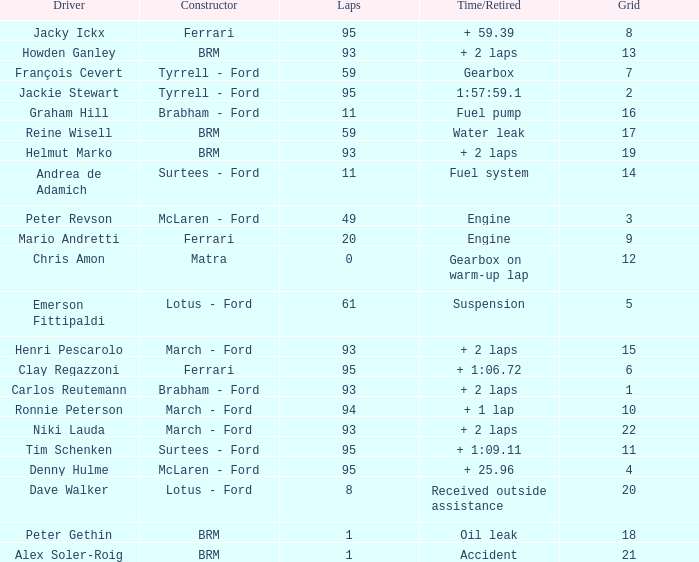How many grids does dave walker have? 1.0. 